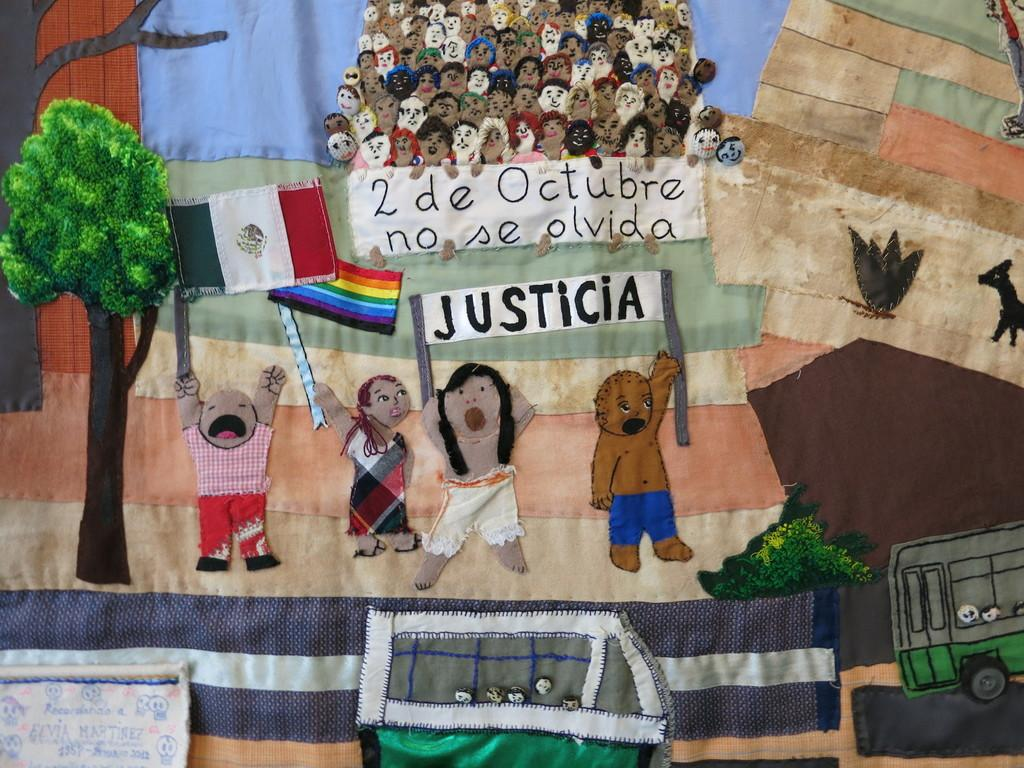What type of object is featured in the image? There is a colorful cloth in the image. What kind of images are depicted on the cloth? The cloth contains pictures of people, trees, flags, boards, an animal, and vehicles. Can you describe the animal depicted on the cloth? Unfortunately, the specific animal cannot be determined from the provided facts. What type of wren can be seen flying over the process in the image? There is no wren or process present in the image; it features a colorful cloth with various pictures. 